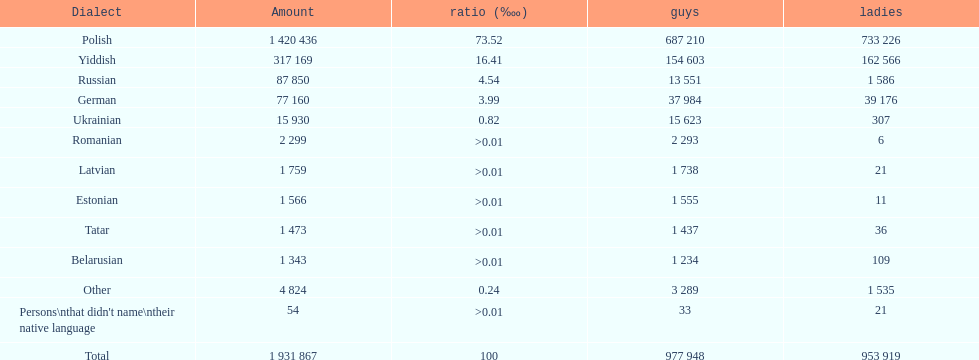Which language had the most number of people speaking it. Polish. 